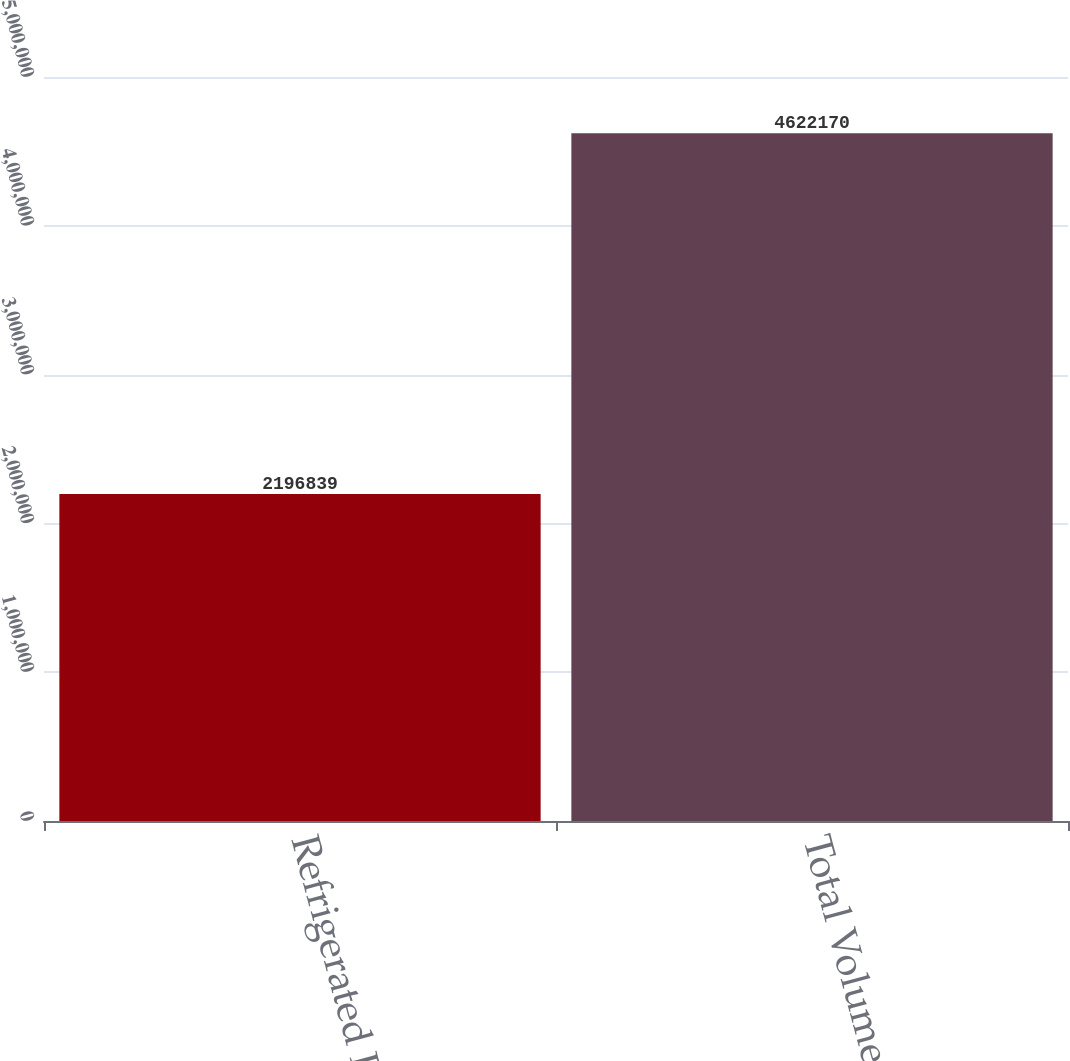Convert chart to OTSL. <chart><loc_0><loc_0><loc_500><loc_500><bar_chart><fcel>Refrigerated Foods<fcel>Total Volume<nl><fcel>2.19684e+06<fcel>4.62217e+06<nl></chart> 